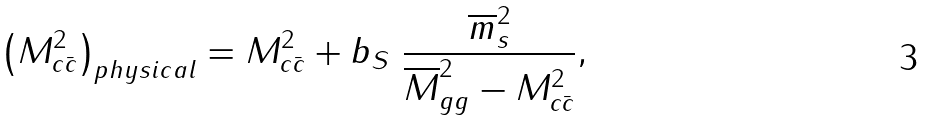<formula> <loc_0><loc_0><loc_500><loc_500>\left ( M _ { c \bar { c } } ^ { 2 } \right ) _ { p h y s i c a l } = M _ { c \bar { c } } ^ { 2 } + b _ { S } \ \frac { \overline { m } _ { s } ^ { 2 } } { \overline { M } _ { g g } ^ { 2 } - M _ { c \bar { c } } ^ { 2 } } ,</formula> 